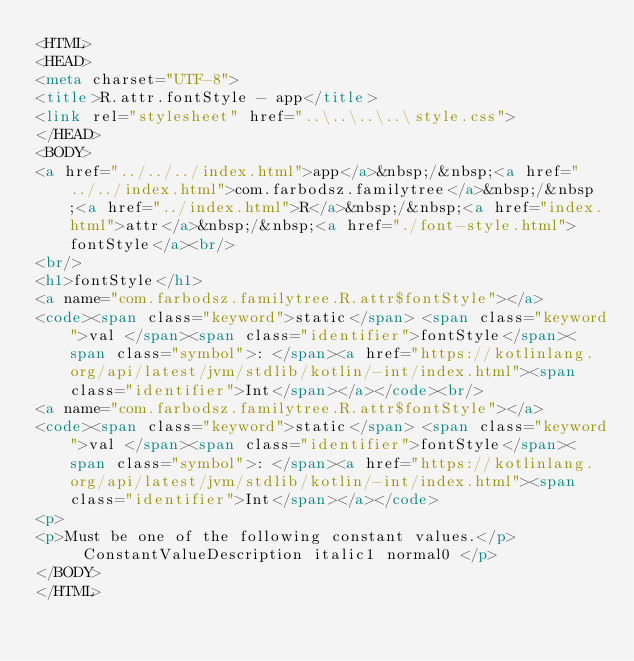Convert code to text. <code><loc_0><loc_0><loc_500><loc_500><_HTML_><HTML>
<HEAD>
<meta charset="UTF-8">
<title>R.attr.fontStyle - app</title>
<link rel="stylesheet" href="..\..\..\..\style.css">
</HEAD>
<BODY>
<a href="../../../index.html">app</a>&nbsp;/&nbsp;<a href="../../index.html">com.farbodsz.familytree</a>&nbsp;/&nbsp;<a href="../index.html">R</a>&nbsp;/&nbsp;<a href="index.html">attr</a>&nbsp;/&nbsp;<a href="./font-style.html">fontStyle</a><br/>
<br/>
<h1>fontStyle</h1>
<a name="com.farbodsz.familytree.R.attr$fontStyle"></a>
<code><span class="keyword">static</span> <span class="keyword">val </span><span class="identifier">fontStyle</span><span class="symbol">: </span><a href="https://kotlinlang.org/api/latest/jvm/stdlib/kotlin/-int/index.html"><span class="identifier">Int</span></a></code><br/>
<a name="com.farbodsz.familytree.R.attr$fontStyle"></a>
<code><span class="keyword">static</span> <span class="keyword">val </span><span class="identifier">fontStyle</span><span class="symbol">: </span><a href="https://kotlinlang.org/api/latest/jvm/stdlib/kotlin/-int/index.html"><span class="identifier">Int</span></a></code>
<p>
<p>Must be one of the following constant values.</p>
     ConstantValueDescription italic1 normal0 </p>
</BODY>
</HTML>
</code> 